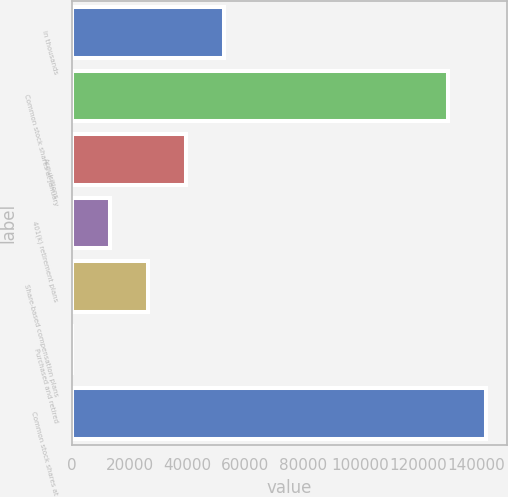Convert chart. <chart><loc_0><loc_0><loc_500><loc_500><bar_chart><fcel>in thousands<fcel>Common stock shares at January<fcel>Acquisitions<fcel>401(k) retirement plans<fcel>Share-based compensation plans<fcel>Purchased and retired<fcel>Common stock shares at<nl><fcel>52763.6<fcel>130200<fcel>39573<fcel>13191.9<fcel>26382.5<fcel>1.32<fcel>143391<nl></chart> 